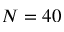<formula> <loc_0><loc_0><loc_500><loc_500>N = 4 0</formula> 